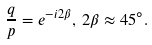<formula> <loc_0><loc_0><loc_500><loc_500>\frac { q } { p } = e ^ { - i 2 \beta } , \, 2 \beta \approx 4 5 ^ { \circ } .</formula> 